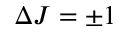<formula> <loc_0><loc_0><loc_500><loc_500>\Delta J = \pm 1</formula> 